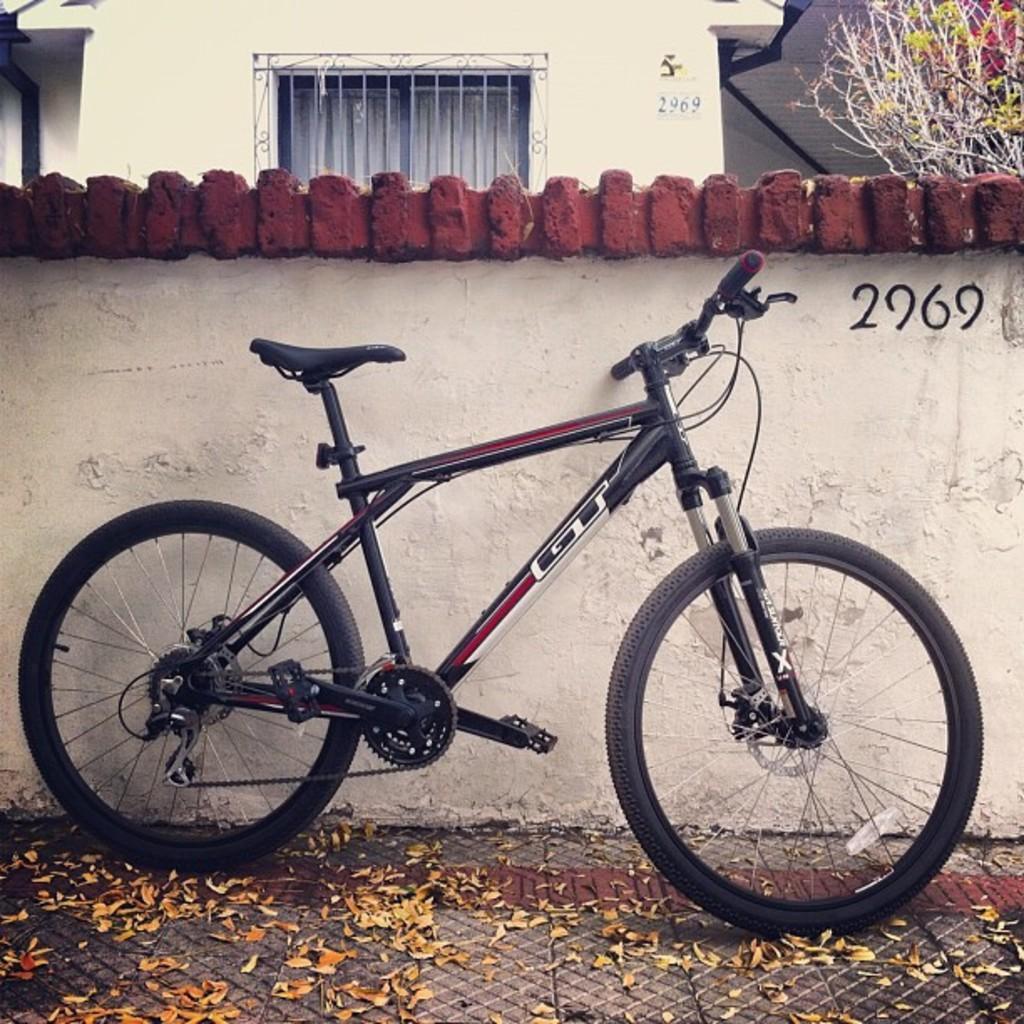How would you summarize this image in a sentence or two? In the background we can see the number digits on the wall. In this picture we can see the bricks, window and a plant. This picture is mainly highlighted with a bicycle. At the bottom portion of the picture we can see the leaves on the floor. 